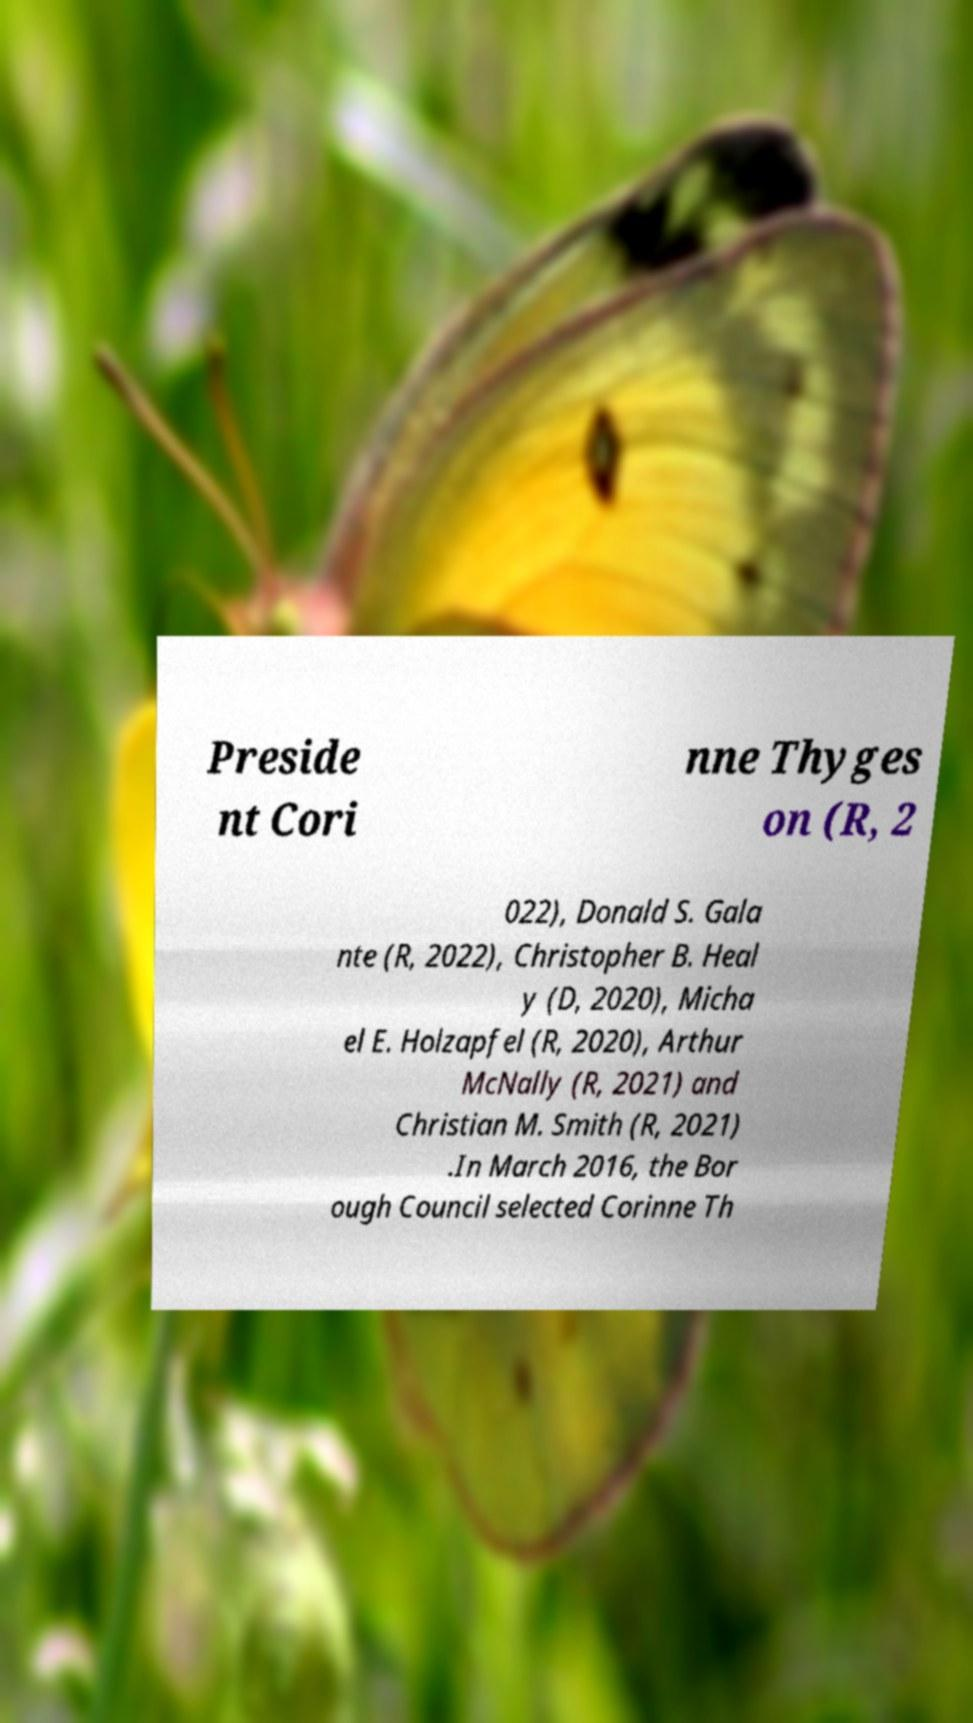For documentation purposes, I need the text within this image transcribed. Could you provide that? Preside nt Cori nne Thyges on (R, 2 022), Donald S. Gala nte (R, 2022), Christopher B. Heal y (D, 2020), Micha el E. Holzapfel (R, 2020), Arthur McNally (R, 2021) and Christian M. Smith (R, 2021) .In March 2016, the Bor ough Council selected Corinne Th 